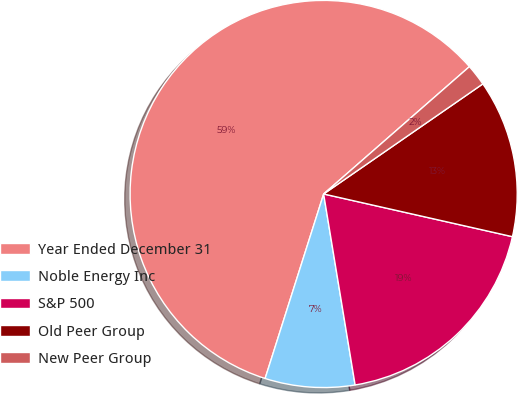Convert chart to OTSL. <chart><loc_0><loc_0><loc_500><loc_500><pie_chart><fcel>Year Ended December 31<fcel>Noble Energy Inc<fcel>S&P 500<fcel>Old Peer Group<fcel>New Peer Group<nl><fcel>58.68%<fcel>7.49%<fcel>18.86%<fcel>13.17%<fcel>1.8%<nl></chart> 